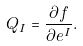<formula> <loc_0><loc_0><loc_500><loc_500>Q _ { I } = \frac { \partial f } { \partial e ^ { I } } .</formula> 